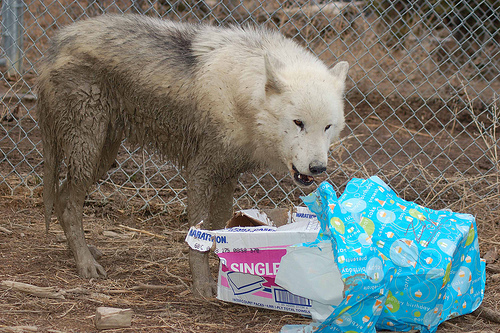<image>
Is there a dog to the left of the plastic cover? Yes. From this viewpoint, the dog is positioned to the left side relative to the plastic cover. Is there a animal to the right of the fence? No. The animal is not to the right of the fence. The horizontal positioning shows a different relationship. Is there a wolf in front of the present? No. The wolf is not in front of the present. The spatial positioning shows a different relationship between these objects. 